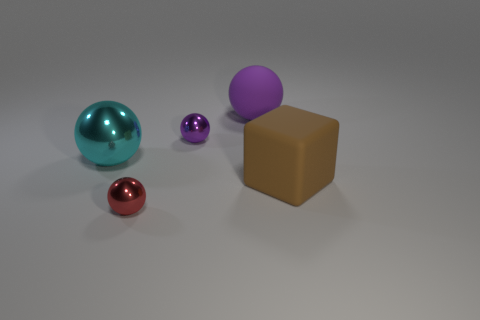Subtract all small purple balls. How many balls are left? 3 Subtract all red spheres. How many spheres are left? 3 Subtract 2 balls. How many balls are left? 2 Add 1 green matte cylinders. How many objects exist? 6 Add 2 spheres. How many spheres are left? 6 Add 5 large brown shiny balls. How many large brown shiny balls exist? 5 Subtract 0 purple cylinders. How many objects are left? 5 Subtract all cubes. How many objects are left? 4 Subtract all purple balls. Subtract all gray cubes. How many balls are left? 2 Subtract all yellow blocks. How many purple spheres are left? 2 